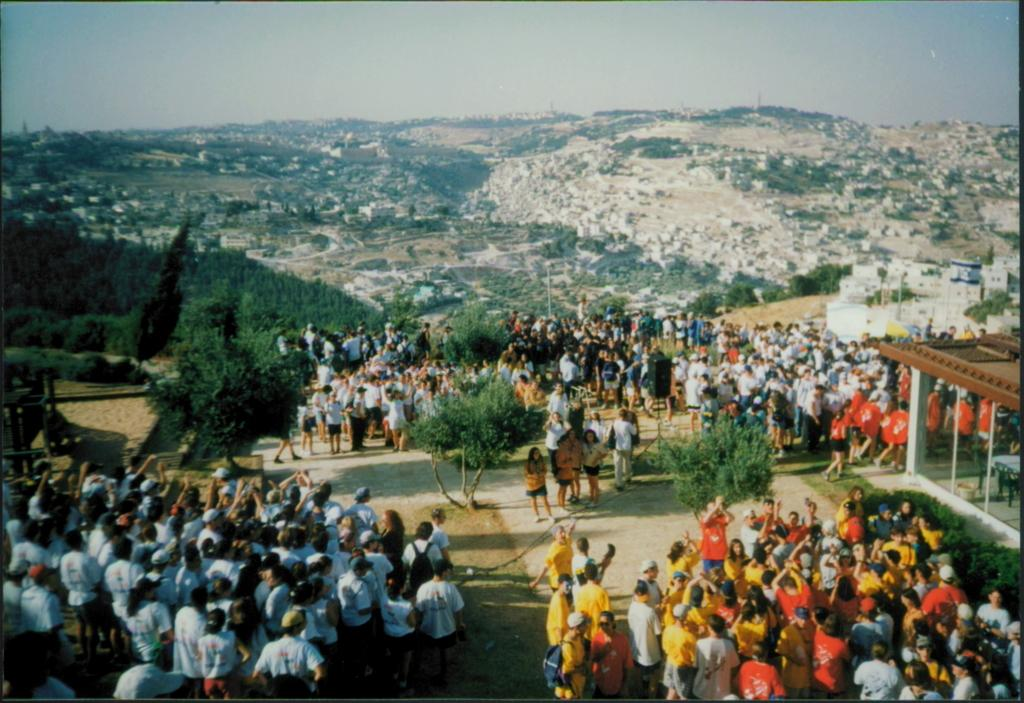How many people are in the group that is visible in the image? There is a group of people standing in the image, but the exact number cannot be determined from the provided facts. What type of structures can be seen in the image? There are buildings in the image. What other natural elements are present in the image? There are trees in the image. What is visible in the background of the image? The sky is visible in the background of the image. What type of leather is used to cover the acoustics in the image? There is no mention of leather or acoustics in the image, so this question cannot be answered definitively. 